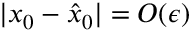Convert formula to latex. <formula><loc_0><loc_0><loc_500><loc_500>| x _ { 0 } - \hat { x } _ { 0 } | = O ( \epsilon )</formula> 